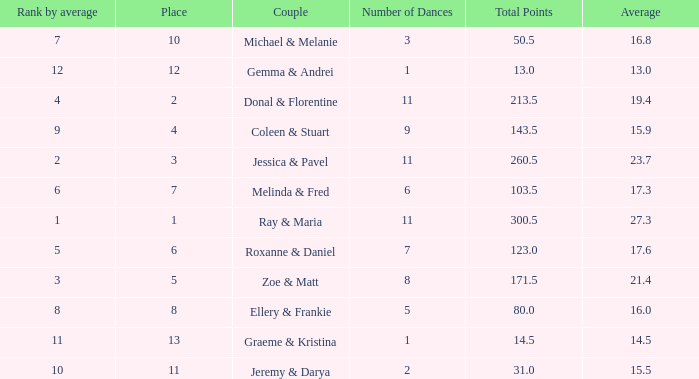If your rank by average is 9, what is the name of the couple? Coleen & Stuart. 